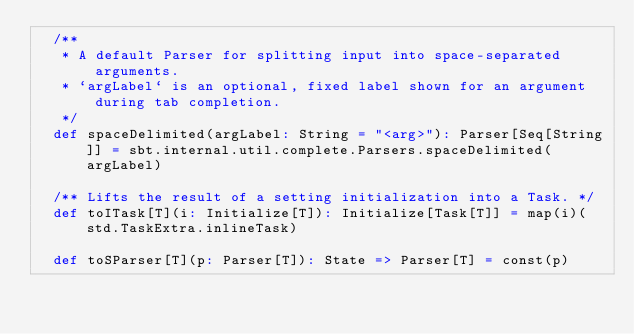Convert code to text. <code><loc_0><loc_0><loc_500><loc_500><_Scala_>  /**
   * A default Parser for splitting input into space-separated arguments.
   * `argLabel` is an optional, fixed label shown for an argument during tab completion.
   */
  def spaceDelimited(argLabel: String = "<arg>"): Parser[Seq[String]] = sbt.internal.util.complete.Parsers.spaceDelimited(argLabel)

  /** Lifts the result of a setting initialization into a Task. */
  def toITask[T](i: Initialize[T]): Initialize[Task[T]] = map(i)(std.TaskExtra.inlineTask)

  def toSParser[T](p: Parser[T]): State => Parser[T] = const(p)</code> 